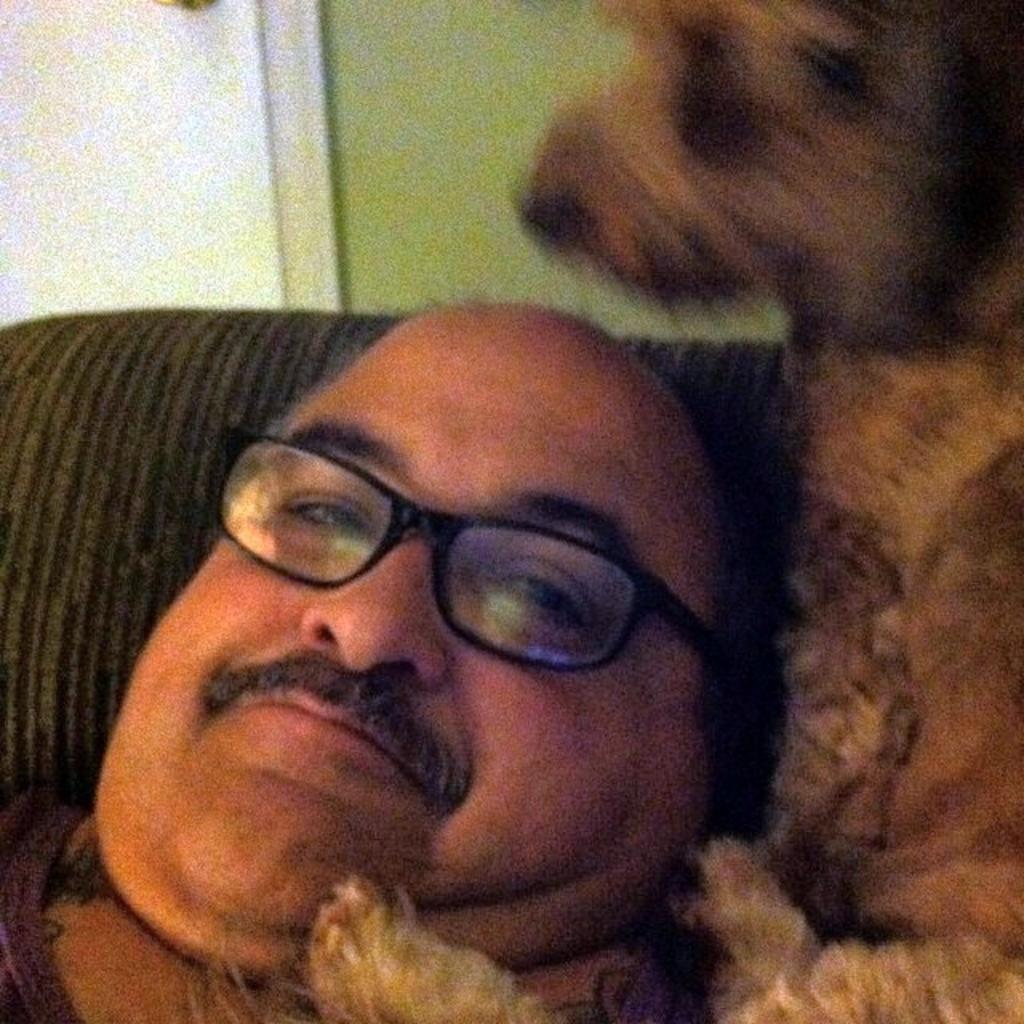What is the person in the image wearing on their face? The person in the image is wearing spectacles. What type of animal is beside the person in the image? There is a dog beside the person in the image. What role does the actor play in the image? There is no actor present in the image, as the main subject is a person wearing spectacles. How many toes can be seen on the person's foot in the image? The image does not show the person's foot, so the number of toes cannot be determined. 